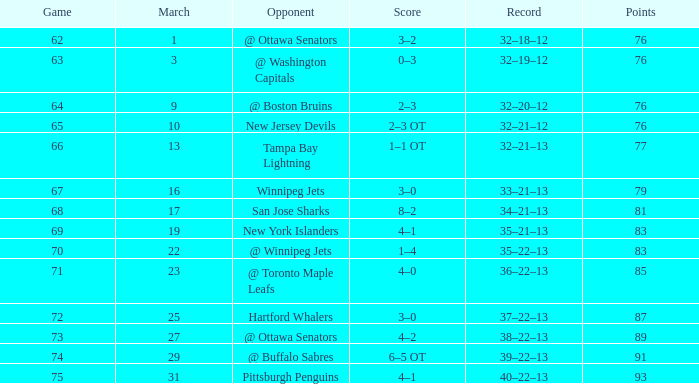How much March has Points of 85? 1.0. 